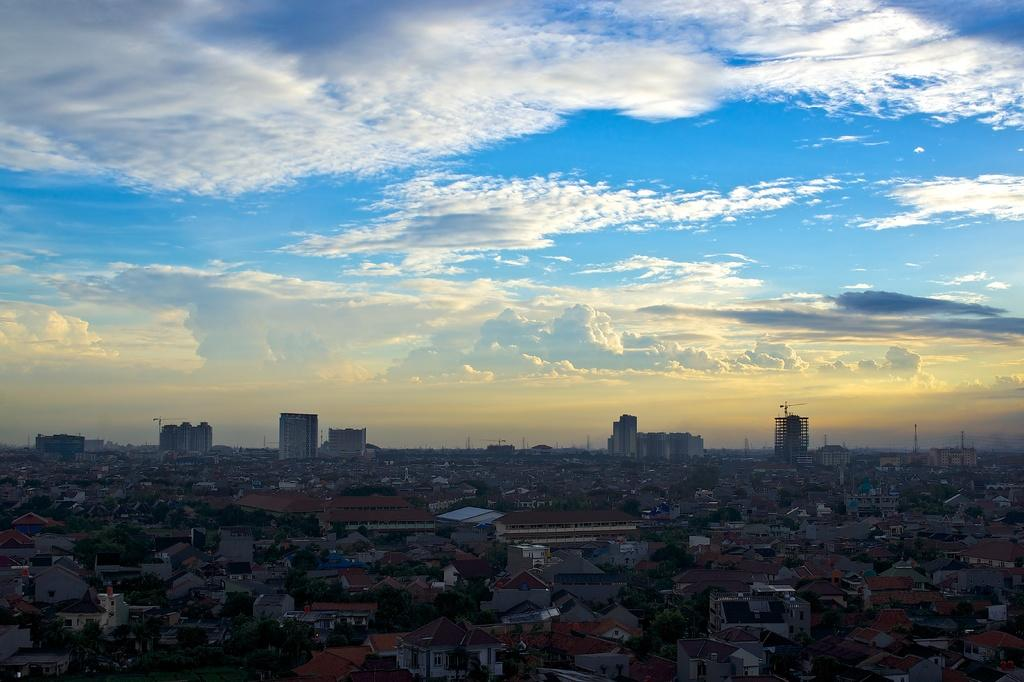What type of location is shown in the image? The image depicts a city. What structures can be seen in the city? There are buildings in the image. Are there any natural elements present in the city? Yes, there are trees in the image. What else can be seen in the image besides buildings and trees? There are poles in the image. What is visible at the top of the image? The sky is visible at the top of the image. Can you describe the sky in the image? Yes, there are clouds in the sky. What type of collar can be seen on the building in the image? There is no collar present on any building in the image. What caption is written on the trees in the image? There is no caption written on any trees in the image; trees do not have captions. What type of mine is visible in the image? There is no mine present in the image; the image depicts a city with buildings, trees, and poles. 